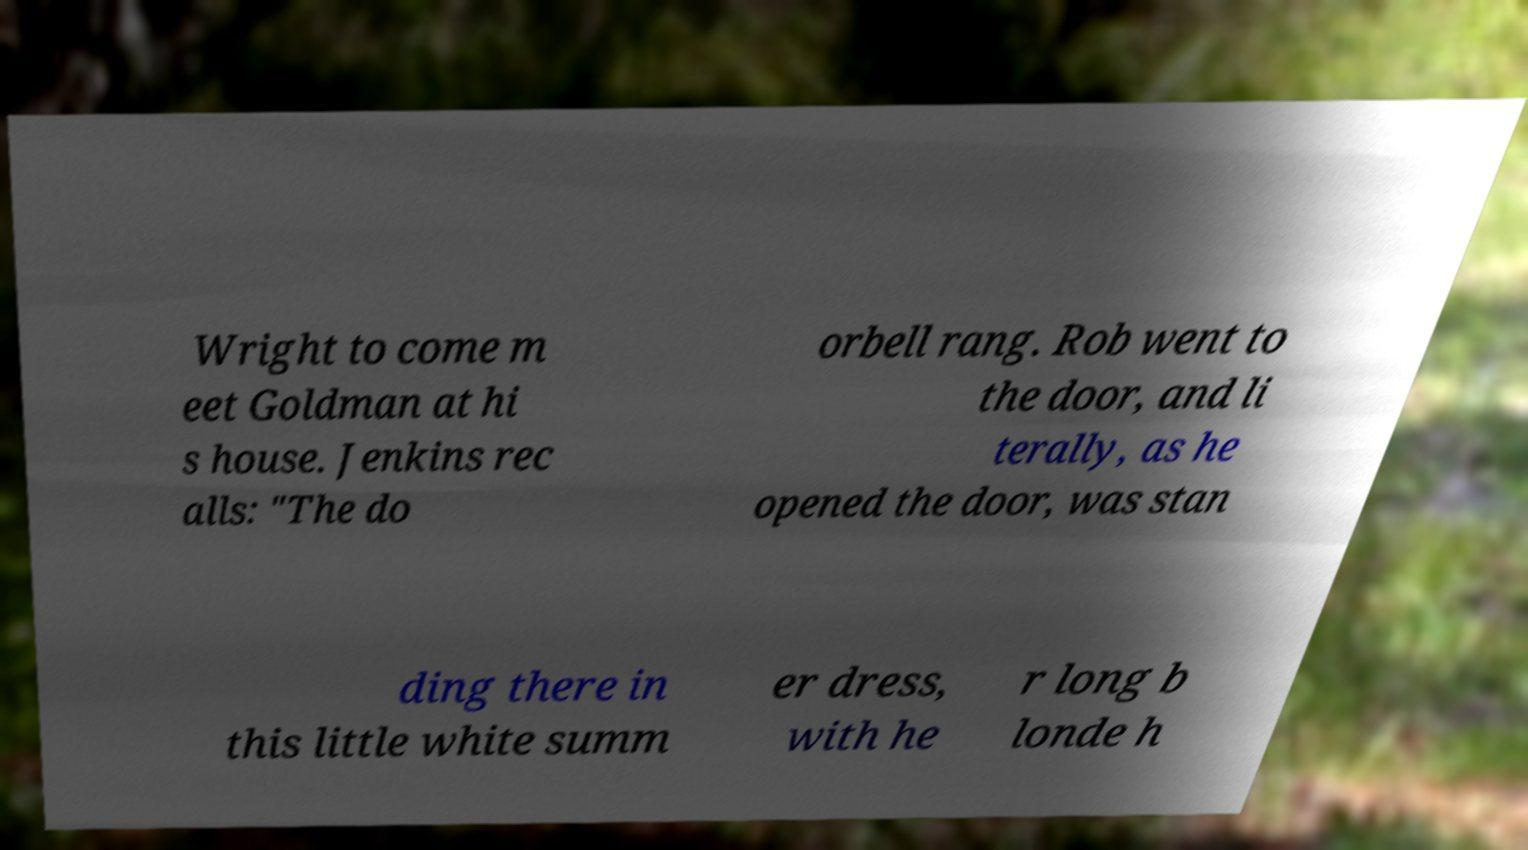Please read and relay the text visible in this image. What does it say? Wright to come m eet Goldman at hi s house. Jenkins rec alls: "The do orbell rang. Rob went to the door, and li terally, as he opened the door, was stan ding there in this little white summ er dress, with he r long b londe h 